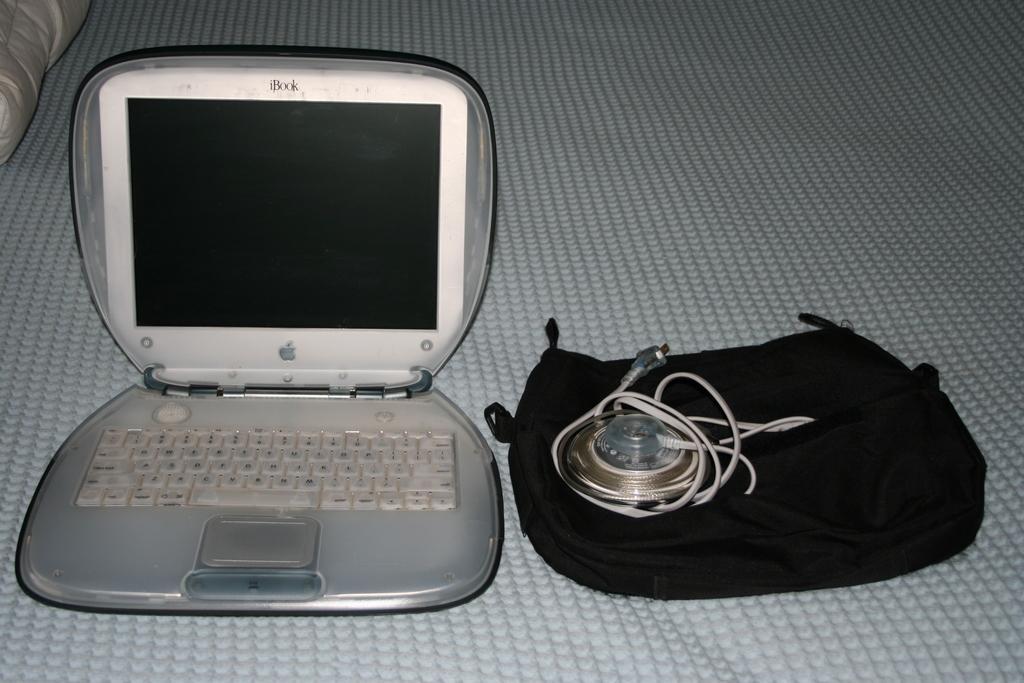Please provide a concise description of this image. In this image I can see a laptop, wires and some other objects on a surface. 